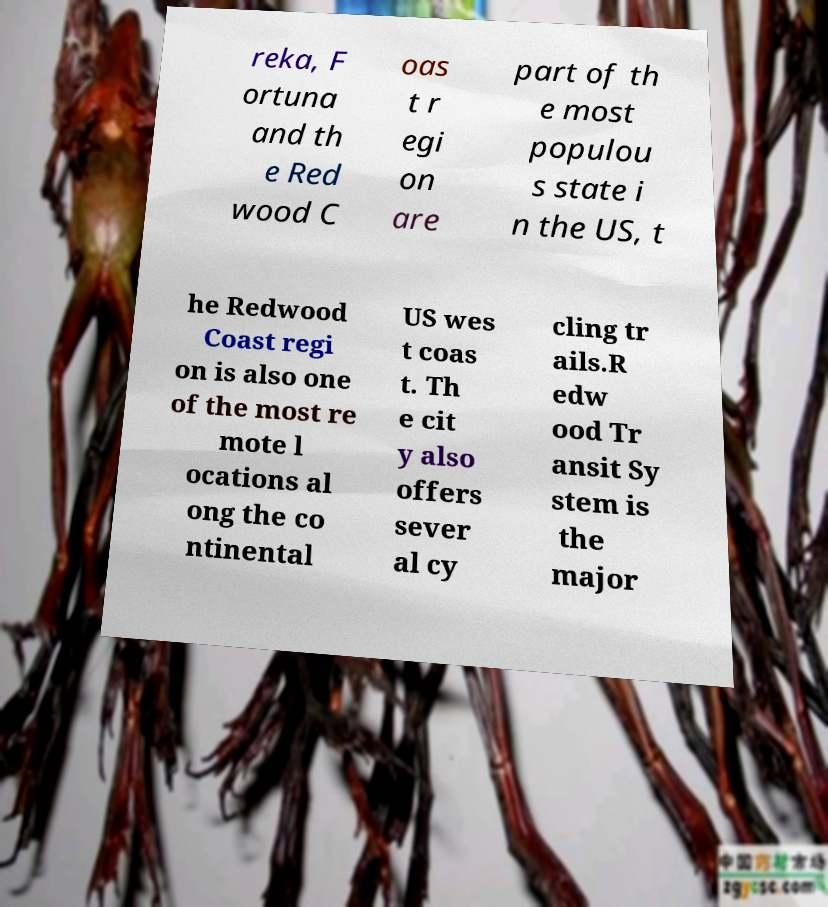Please read and relay the text visible in this image. What does it say? reka, F ortuna and th e Red wood C oas t r egi on are part of th e most populou s state i n the US, t he Redwood Coast regi on is also one of the most re mote l ocations al ong the co ntinental US wes t coas t. Th e cit y also offers sever al cy cling tr ails.R edw ood Tr ansit Sy stem is the major 